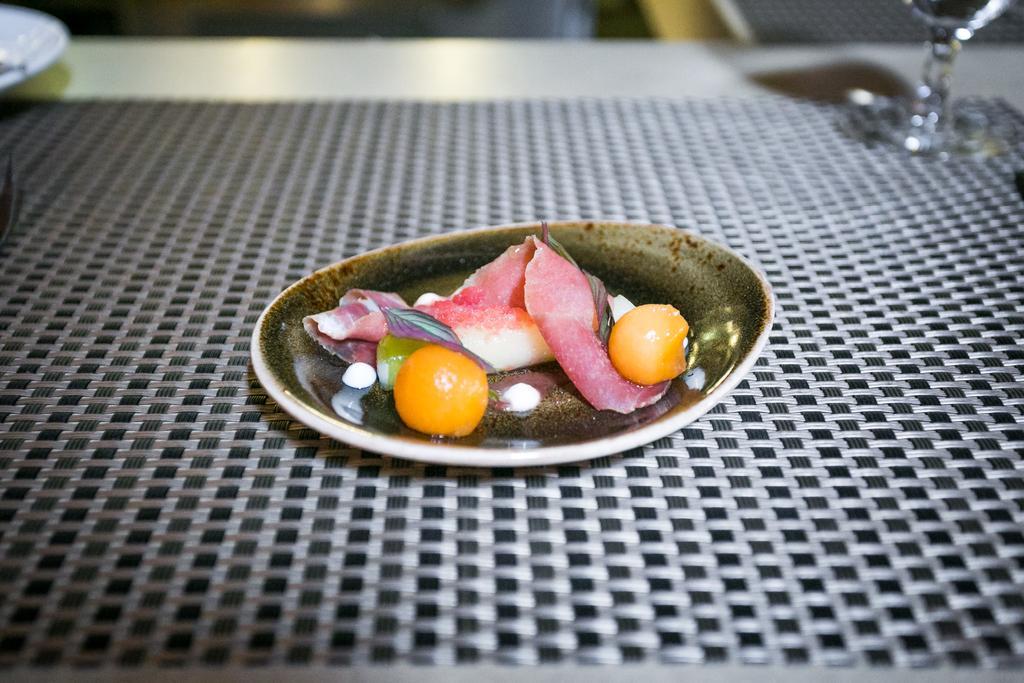How would you summarize this image in a sentence or two? In this image we can see some food in a plate which is placed on the table. We can also see a plate and a glass beside it. 